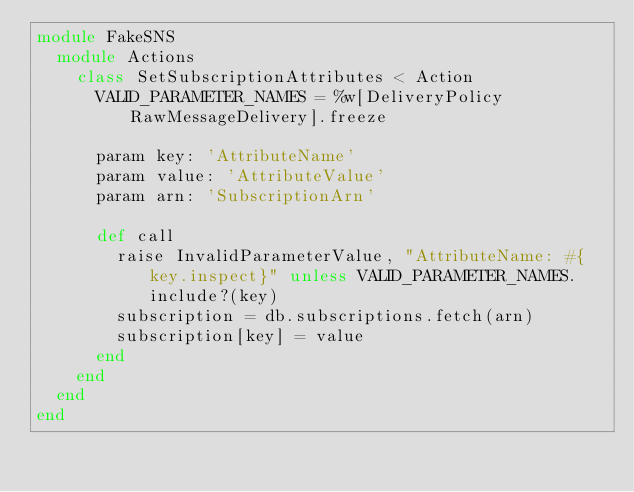Convert code to text. <code><loc_0><loc_0><loc_500><loc_500><_Ruby_>module FakeSNS
  module Actions
    class SetSubscriptionAttributes < Action
      VALID_PARAMETER_NAMES = %w[DeliveryPolicy RawMessageDelivery].freeze

      param key: 'AttributeName'
      param value: 'AttributeValue'
      param arn: 'SubscriptionArn'

      def call
        raise InvalidParameterValue, "AttributeName: #{key.inspect}" unless VALID_PARAMETER_NAMES.include?(key)
        subscription = db.subscriptions.fetch(arn)
        subscription[key] = value
      end
    end
  end
end
</code> 